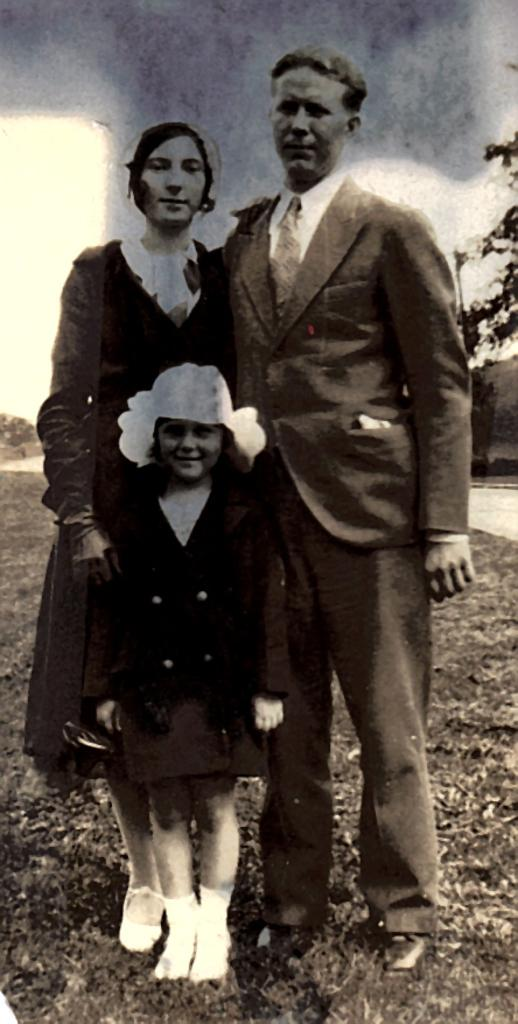What is happening in the middle of the image? There are people standing in the middle of the image. How are the people in the image feeling? The people are smiling. What type of natural environment is visible in the background of the image? There is grass and trees visible in the background of the image. What flavor of ice cream is being served at the airport in the image? There is no ice cream or airport present in the image; it features people standing in a natural environment. What type of stem can be seen growing from the trees in the image? There is no stem visible in the image; only the trees themselves are present. 